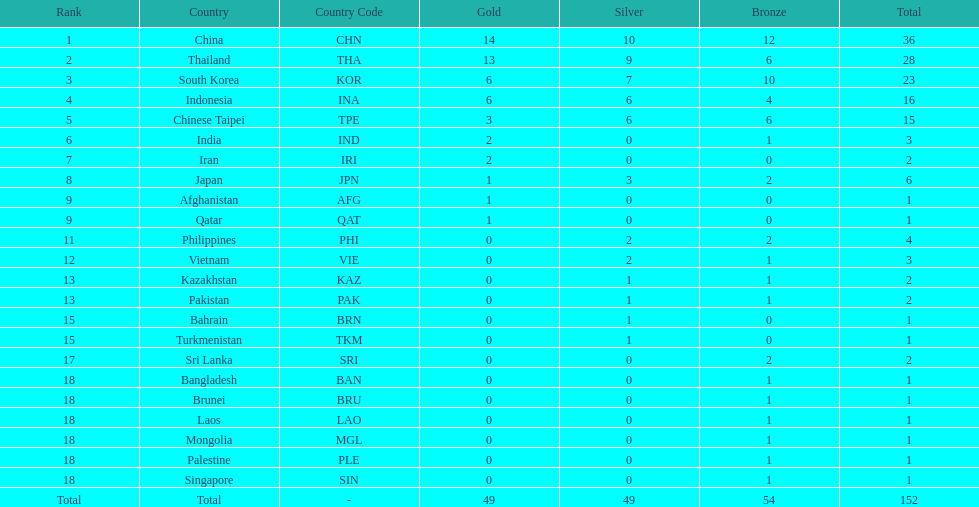Which nation finished first in total medals earned? China (CHN). 